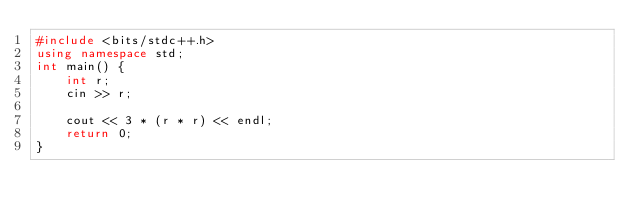<code> <loc_0><loc_0><loc_500><loc_500><_C++_>#include <bits/stdc++.h>
using namespace std;
int main() {
    int r;
    cin >> r;

    cout << 3 * (r * r) << endl;
    return 0;
}
</code> 